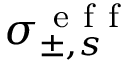Convert formula to latex. <formula><loc_0><loc_0><loc_500><loc_500>\sigma _ { \pm , s } ^ { e f f }</formula> 